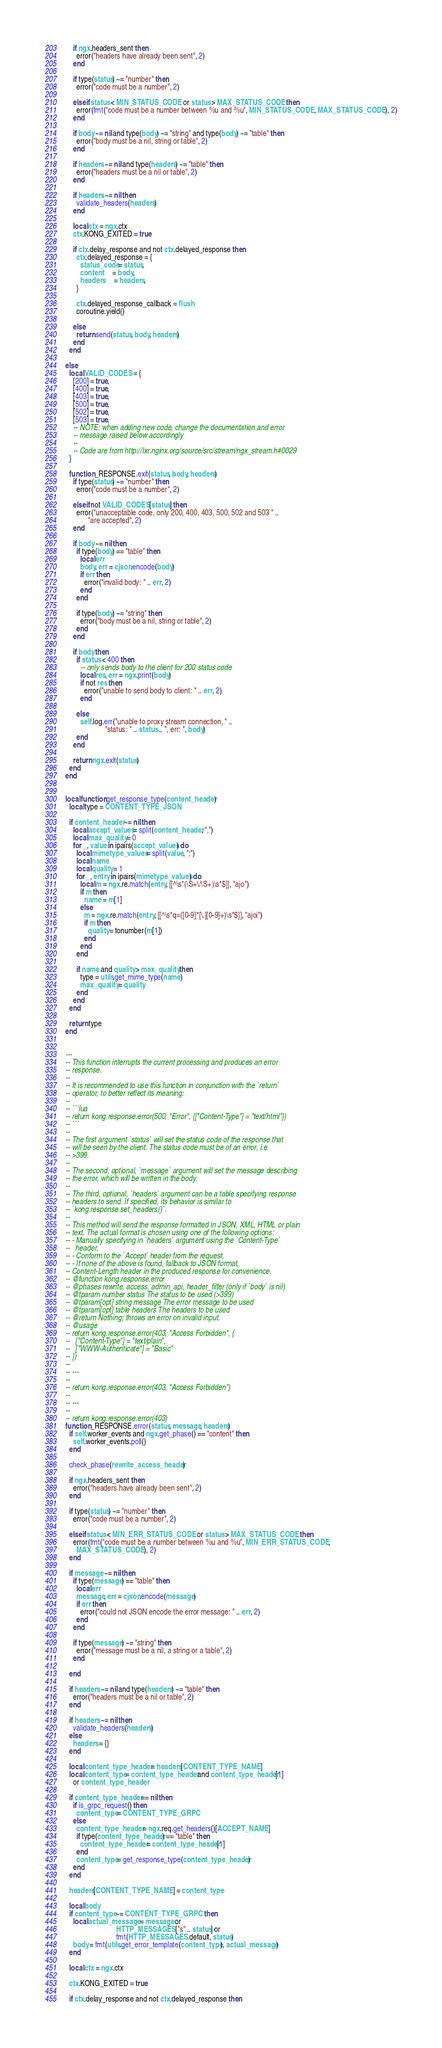<code> <loc_0><loc_0><loc_500><loc_500><_Lua_>      if ngx.headers_sent then
        error("headers have already been sent", 2)
      end

      if type(status) ~= "number" then
        error("code must be a number", 2)

      elseif status < MIN_STATUS_CODE or status > MAX_STATUS_CODE then
        error(fmt("code must be a number between %u and %u", MIN_STATUS_CODE, MAX_STATUS_CODE), 2)
      end

      if body ~= nil and type(body) ~= "string" and type(body) ~= "table" then
        error("body must be a nil, string or table", 2)
      end

      if headers ~= nil and type(headers) ~= "table" then
        error("headers must be a nil or table", 2)
      end

      if headers ~= nil then
        validate_headers(headers)
      end

      local ctx = ngx.ctx
      ctx.KONG_EXITED = true

      if ctx.delay_response and not ctx.delayed_response then
        ctx.delayed_response = {
          status_code = status,
          content     = body,
          headers     = headers,
        }

        ctx.delayed_response_callback = flush
        coroutine.yield()

      else
        return send(status, body, headers)
      end
    end

  else
    local VALID_CODES = {
      [200] = true,
      [400] = true,
      [403] = true,
      [500] = true,
      [502] = true,
      [503] = true,
      -- NOTE: when adding new code, change the documentation and error
      -- message raised below accordingly
      --
      -- Code are from http://lxr.nginx.org/source/src/stream/ngx_stream.h#0029
    }

    function _RESPONSE.exit(status, body, headers)
      if type(status) ~= "number" then
        error("code must be a number", 2)

      elseif not VALID_CODES[status] then
        error("unacceptable code, only 200, 400, 403, 500, 502 and 503 " ..
              "are accepted", 2)
      end

      if body ~= nil then
        if type(body) == "table" then
          local err
          body, err = cjson.encode(body)
          if err then
            error("invalid body: " .. err, 2)
          end
        end

        if type(body) ~= "string" then
          error("body must be a nil, string or table", 2)
        end
      end

      if body then
        if status < 400 then
          -- only sends body to the client for 200 status code
          local res, err = ngx.print(body)
          if not res then
            error("unable to send body to client: " .. err, 2)
          end

        else
          self.log.err("unable to proxy stream connection, " ..
                       "status: " .. status .. ", err: ", body)
        end
      end

      return ngx.exit(status)
    end
  end


  local function get_response_type(content_header)
    local type = CONTENT_TYPE_JSON

    if content_header ~= nil then
      local accept_values = split(content_header, ",")
      local max_quality = 0
      for _, value in ipairs(accept_values) do
        local mimetype_values = split(value, ";")
        local name
        local quality = 1
        for _, entry in ipairs(mimetype_values) do
          local m = ngx.re.match(entry, [[^\s*(\S+\/\S+)\s*$]], "ajo")
          if m then
            name = m[1]
          else
            m = ngx.re.match(entry, [[^\s*q=([0-9]*[\.][0-9]+)\s*$]], "ajoi")
            if m then
              quality = tonumber(m[1])
            end
          end
        end

        if name and quality > max_quality then
          type = utils.get_mime_type(name)
          max_quality = quality
        end
      end
    end

    return type
  end


  ---
  -- This function interrupts the current processing and produces an error
  -- response.
  --
  -- It is recommended to use this function in conjunction with the `return`
  -- operator, to better reflect its meaning:
  --
  -- ```lua
  -- return kong.response.error(500, "Error", {["Content-Type"] = "text/html"})
  -- ```
  --
  -- The first argument `status` will set the status code of the response that
  -- will be seen by the client. The status code must be of an error, i.e.
  -- >399.
  --
  -- The second, optional, `message` argument will set the message describing
  -- the error, which will be written in the body.
  --
  -- The third, optional, `headers` argument can be a table specifying response
  -- headers to send. If specified, its behavior is similar to
  -- `kong.response.set_headers()`.
  --
  -- This method will send the response formatted in JSON, XML, HTML or plain
  -- text. The actual format is chosen using one of the following options:
  -- - Manually specifying in `headers` argument using the `Content-Type`
  --   header.
  -- - Conform to the `Accept` header from the request.
  -- - If none of the above is found, fallback to JSON format.
  -- Content-Length header in the produced response for convenience.
  -- @function kong.response.error
  -- @phases rewrite, access, admin_api, header_filter (only if `body` is nil)
  -- @tparam number status The status to be used (>399)
  -- @tparam[opt] string message The error message to be used
  -- @tparam[opt] table headers The headers to be used
  -- @return Nothing; throws an error on invalid input.
  -- @usage
  -- return kong.response.error(403, "Access Forbidden", {
  --   ["Content-Type"] = "text/plain",
  --   ["WWW-Authenticate"] = "Basic"
  -- })
  --
  -- ---
  --
  -- return kong.response.error(403, "Access Forbidden")
  --
  -- ---
  --
  -- return kong.response.error(403)
  function _RESPONSE.error(status, message, headers)
    if self.worker_events and ngx.get_phase() == "content" then
      self.worker_events.poll()
    end

    check_phase(rewrite_access_header)

    if ngx.headers_sent then
      error("headers have already been sent", 2)
    end

    if type(status) ~= "number" then
      error("code must be a number", 2)

    elseif status < MIN_ERR_STATUS_CODE or status > MAX_STATUS_CODE then
      error(fmt("code must be a number between %u and %u", MIN_ERR_STATUS_CODE,
        MAX_STATUS_CODE), 2)
    end

    if message ~= nil then
      if type(message) == "table" then
        local err
        message, err = cjson.encode(message)
        if err then
          error("could not JSON encode the error message: " .. err, 2)
        end
      end

      if type(message) ~= "string" then
        error("message must be a nil, a string or a table", 2)
      end

    end

    if headers ~= nil and type(headers) ~= "table" then
      error("headers must be a nil or table", 2)
    end

    if headers ~= nil then
      validate_headers(headers)
    else
      headers = {}
    end

    local content_type_header = headers[CONTENT_TYPE_NAME]
    local content_type = content_type_header and content_type_header[1]
      or content_type_header

    if content_type_header == nil then
      if is_grpc_request() then
        content_type = CONTENT_TYPE_GRPC
      else
        content_type_header = ngx.req.get_headers()[ACCEPT_NAME]
        if type(content_type_header) == "table" then
          content_type_header = content_type_header[1]
        end
        content_type = get_response_type(content_type_header)
      end
    end

    headers[CONTENT_TYPE_NAME] = content_type

    local body
    if content_type ~= CONTENT_TYPE_GRPC then
      local actual_message = message or
                             HTTP_MESSAGES["s" .. status] or
                             fmt(HTTP_MESSAGES.default, status)
      body = fmt(utils.get_error_template(content_type), actual_message)
    end

    local ctx = ngx.ctx

    ctx.KONG_EXITED = true

    if ctx.delay_response and not ctx.delayed_response then</code> 